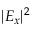Convert formula to latex. <formula><loc_0><loc_0><loc_500><loc_500>| E _ { x } | ^ { 2 }</formula> 